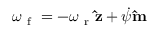<formula> <loc_0><loc_0><loc_500><loc_500>\omega _ { f } = - \omega _ { r } \hat { z } + \dot { \psi } \hat { m }</formula> 